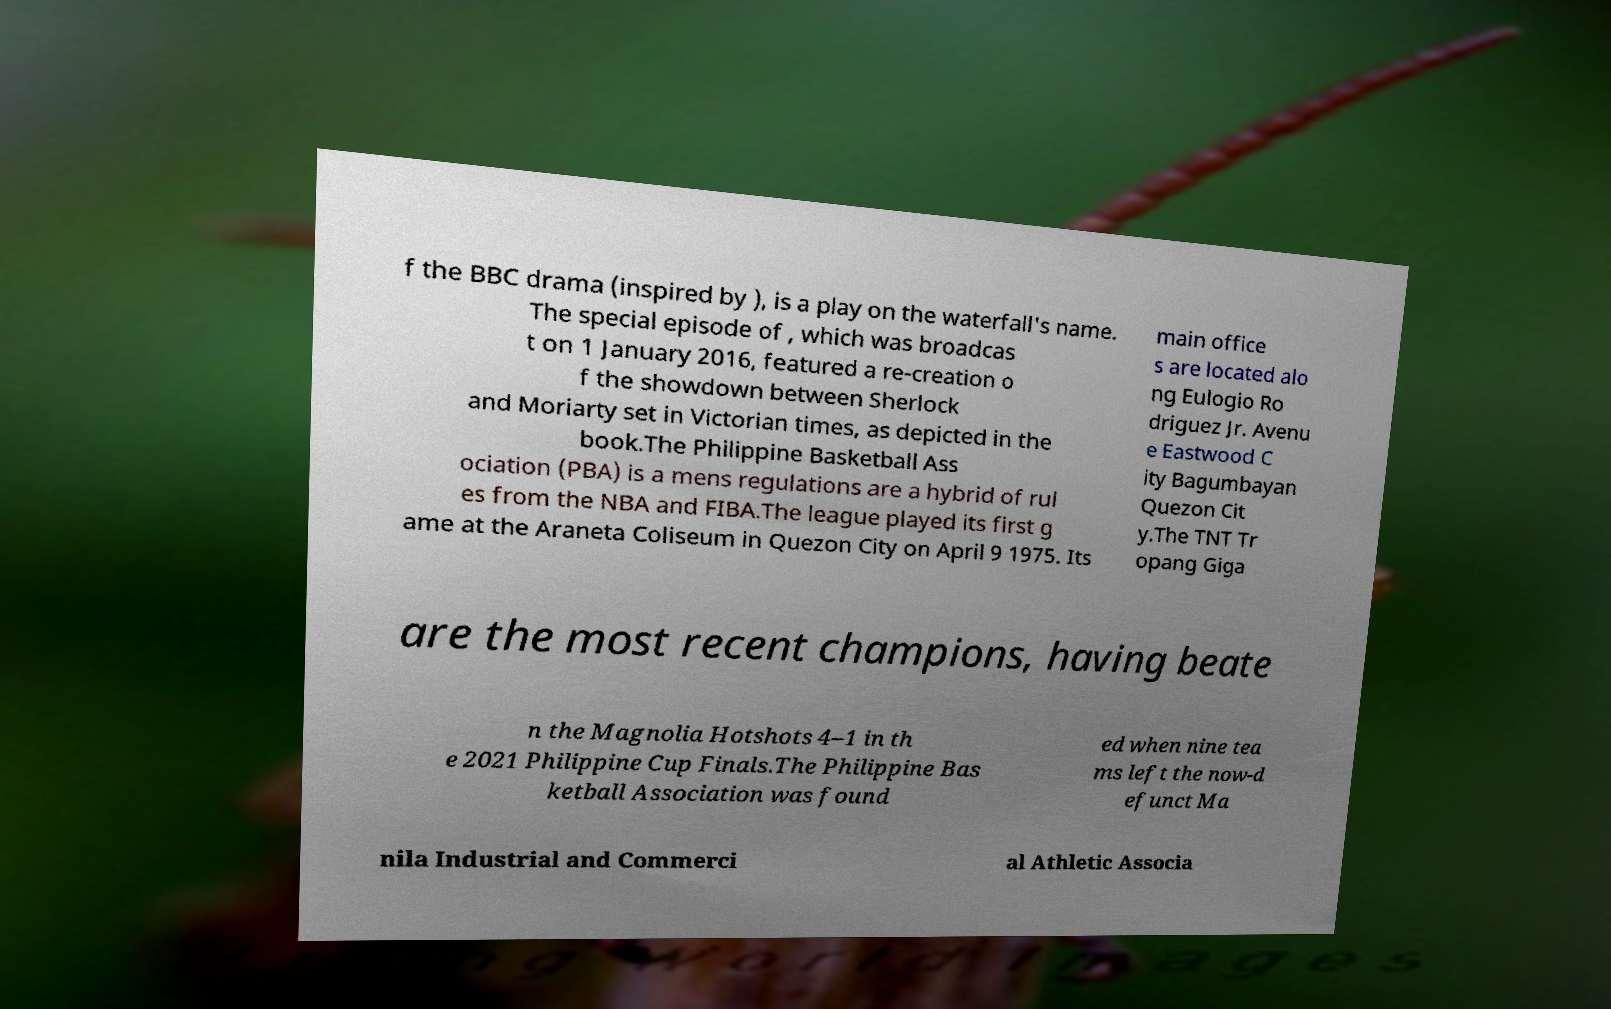Can you accurately transcribe the text from the provided image for me? f the BBC drama (inspired by ), is a play on the waterfall's name. The special episode of , which was broadcas t on 1 January 2016, featured a re-creation o f the showdown between Sherlock and Moriarty set in Victorian times, as depicted in the book.The Philippine Basketball Ass ociation (PBA) is a mens regulations are a hybrid of rul es from the NBA and FIBA.The league played its first g ame at the Araneta Coliseum in Quezon City on April 9 1975. Its main office s are located alo ng Eulogio Ro driguez Jr. Avenu e Eastwood C ity Bagumbayan Quezon Cit y.The TNT Tr opang Giga are the most recent champions, having beate n the Magnolia Hotshots 4–1 in th e 2021 Philippine Cup Finals.The Philippine Bas ketball Association was found ed when nine tea ms left the now-d efunct Ma nila Industrial and Commerci al Athletic Associa 